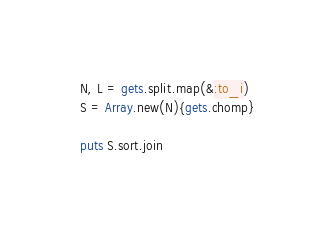<code> <loc_0><loc_0><loc_500><loc_500><_Ruby_>N, L = gets.split.map(&:to_i)
S = Array.new(N){gets.chomp}

puts S.sort.join</code> 